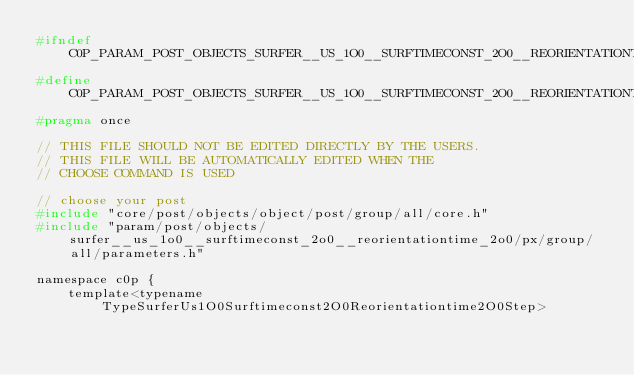<code> <loc_0><loc_0><loc_500><loc_500><_C_>#ifndef C0P_PARAM_POST_OBJECTS_SURFER__US_1O0__SURFTIMECONST_2O0__REORIENTATIONTIME_2O0_PX_GROUP_CHOICE_H
#define C0P_PARAM_POST_OBJECTS_SURFER__US_1O0__SURFTIMECONST_2O0__REORIENTATIONTIME_2O0_PX_GROUP_CHOICE_H
#pragma once

// THIS FILE SHOULD NOT BE EDITED DIRECTLY BY THE USERS.
// THIS FILE WILL BE AUTOMATICALLY EDITED WHEN THE
// CHOOSE COMMAND IS USED

// choose your post
#include "core/post/objects/object/post/group/all/core.h"
#include "param/post/objects/surfer__us_1o0__surftimeconst_2o0__reorientationtime_2o0/px/group/all/parameters.h"

namespace c0p {
    template<typename TypeSurferUs1O0Surftimeconst2O0Reorientationtime2O0Step></code> 